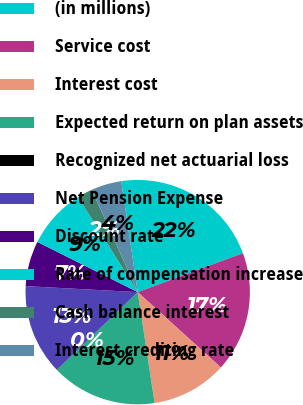Convert chart. <chart><loc_0><loc_0><loc_500><loc_500><pie_chart><fcel>(in millions)<fcel>Service cost<fcel>Interest cost<fcel>Expected return on plan assets<fcel>Recognized net actuarial loss<fcel>Net Pension Expense<fcel>Discount rate<fcel>Rate of compensation increase<fcel>Cash balance interest<fcel>Interest crediting rate<nl><fcel>21.7%<fcel>17.37%<fcel>10.87%<fcel>15.2%<fcel>0.03%<fcel>13.03%<fcel>6.53%<fcel>8.7%<fcel>2.2%<fcel>4.37%<nl></chart> 